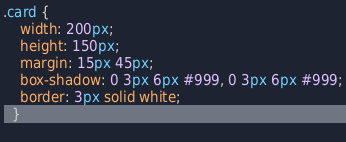<code> <loc_0><loc_0><loc_500><loc_500><_CSS_>.card {
    width: 200px;
    height: 150px;
    margin: 15px 45px;
    box-shadow: 0 3px 6px #999, 0 3px 6px #999;
    border: 3px solid white;
  }
  </code> 